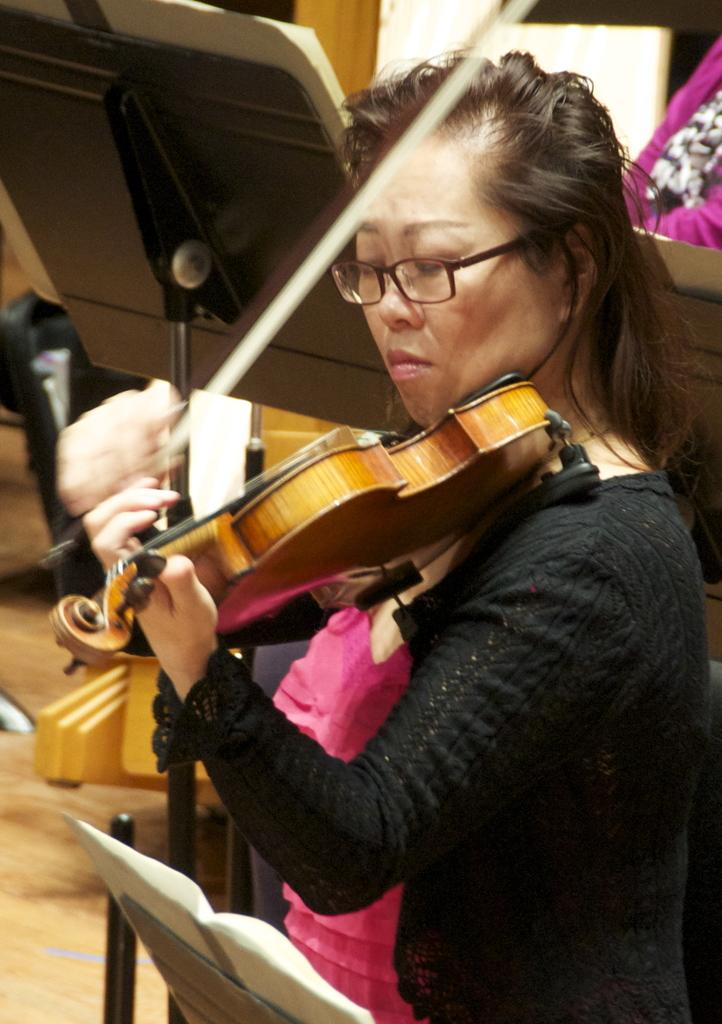Who is present in the image? There is a woman in the image. What is the woman holding in the image? The woman is holding a musical instrument. What else can be seen in the image besides the woman and the musical instrument? There are stands visible in the image. What type of cat can be seen playing with bells in the image? There is no cat or bells present in the image; it features a woman holding a musical instrument and stands. What kind of glass object is visible on the stands in the image? There is no glass object visible on the stands in the image. 